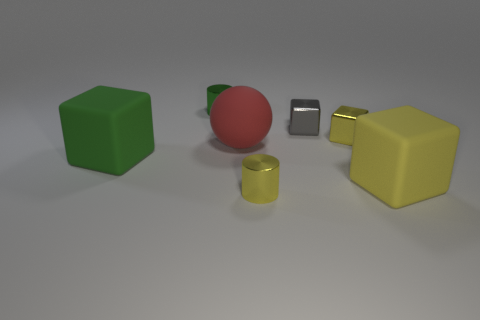What is the color of the other block that is the same size as the yellow metal block?
Provide a succinct answer. Gray. The gray object that is the same size as the green shiny cylinder is what shape?
Your answer should be very brief. Cube. There is another tiny thing that is the same shape as the green metal object; what color is it?
Give a very brief answer. Yellow. How many things are either big yellow rubber cubes or brown matte objects?
Provide a succinct answer. 1. Do the object that is to the right of the yellow metallic cube and the metallic object on the left side of the big sphere have the same shape?
Ensure brevity in your answer.  No. There is a small yellow metallic object that is in front of the big red sphere; what shape is it?
Offer a terse response. Cylinder. Are there the same number of red spheres that are in front of the large green rubber cube and tiny green metallic things in front of the small gray metallic block?
Your answer should be very brief. Yes. How many objects are either gray metallic objects or tiny cylinders in front of the large yellow cube?
Offer a terse response. 2. There is a thing that is in front of the tiny green shiny object and left of the large red object; what is its shape?
Keep it short and to the point. Cube. What is the material of the yellow thing that is behind the matte cube that is on the right side of the green cylinder?
Provide a succinct answer. Metal. 